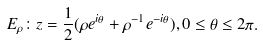Convert formula to latex. <formula><loc_0><loc_0><loc_500><loc_500>E _ { \rho } \colon z = \frac { 1 } { 2 } ( \rho e ^ { i \theta } + \rho ^ { - 1 } e ^ { - i \theta } ) , 0 \leq \theta \leq 2 \pi .</formula> 